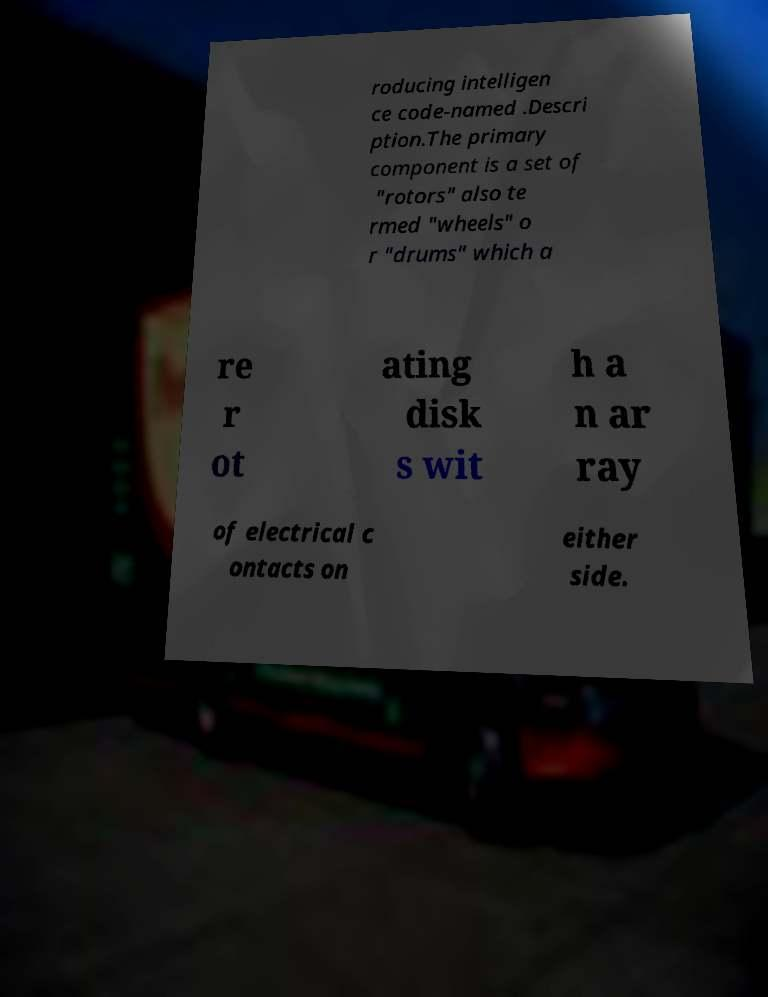For documentation purposes, I need the text within this image transcribed. Could you provide that? roducing intelligen ce code-named .Descri ption.The primary component is a set of "rotors" also te rmed "wheels" o r "drums" which a re r ot ating disk s wit h a n ar ray of electrical c ontacts on either side. 